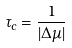Convert formula to latex. <formula><loc_0><loc_0><loc_500><loc_500>\tau _ { c } = \frac { 1 } { | \Delta \mu | }</formula> 